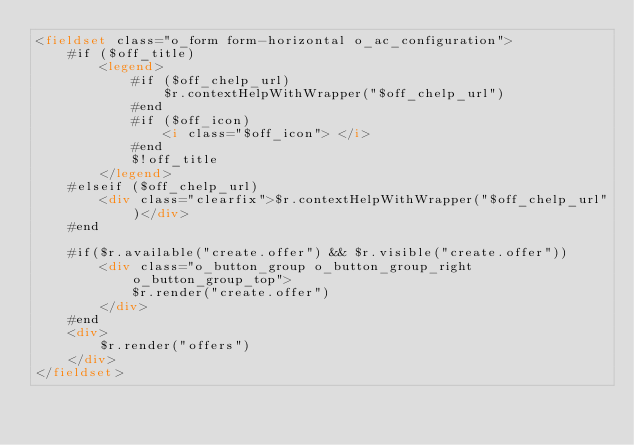Convert code to text. <code><loc_0><loc_0><loc_500><loc_500><_HTML_><fieldset class="o_form form-horizontal o_ac_configuration">
	#if ($off_title) 
		<legend>		
			#if ($off_chelp_url) 
				$r.contextHelpWithWrapper("$off_chelp_url")
			#end		
			#if ($off_icon)
				<i class="$off_icon"> </i>
			#end
			$!off_title
		</legend> 
	#elseif ($off_chelp_url) 
		<div class="clearfix">$r.contextHelpWithWrapper("$off_chelp_url")</div>
	#end
	
	#if($r.available("create.offer") && $r.visible("create.offer"))
		<div class="o_button_group o_button_group_right o_button_group_top">
			$r.render("create.offer")
		</div>
	#end
	<div>
		$r.render("offers")
	</div>
</fieldset></code> 